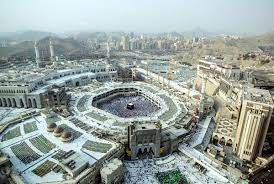What do you think is going on in this snapshot?
 The image presents an aerial view of the Great Mosque of Mecca, the holiest site in Islam. The mosque is a sprawling white structure, punctuated by multiple minarets and domes that reach towards the sky. At the heart of the mosque's courtyard stands the Kaaba, a black cube-shaped building that serves as the focal point of the image. This sacred edifice is surrounded by a sea of high-rise buildings that form the cityscape of Mecca. In the distance, the rugged outlines of mountains can be seen, adding a natural element to the urban panorama. The image is captured from a high angle, providing a comprehensive view of the mosque and the city that surrounds it. The contrast between the white mosque, the black Kaaba, and the grey cityscape creates a visually striking image. The perspective of the image emphasizes the significance of the Kaaba and the Great Mosque within the urban environment of Mecca. 